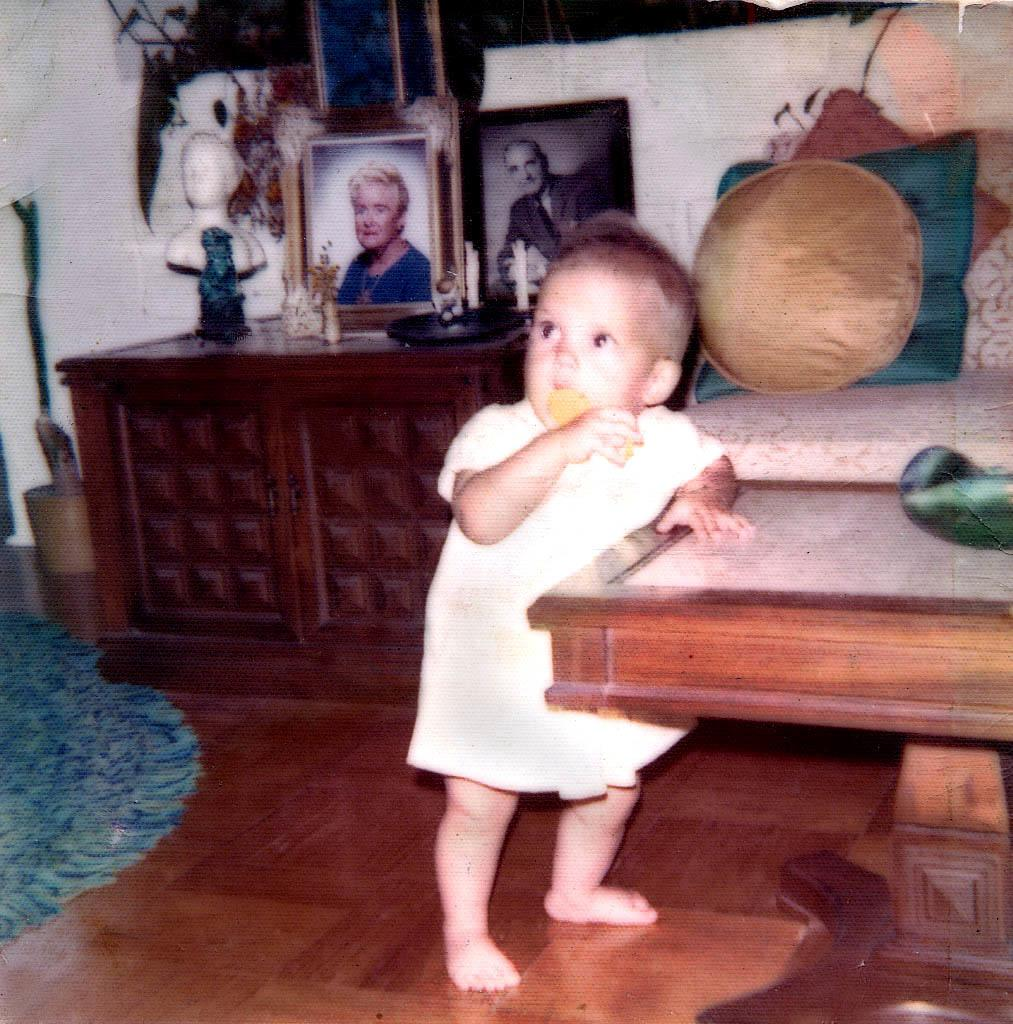What is the main subject of the image? There is a child standing in the image. What can be seen in the background of the image? There are frames and a sofa with cushions in the background of the image. What type of carriage is being used by the child in the image? There is no carriage present in the image; the child is standing. What year is depicted in the image? The provided facts do not mention any specific year, and the image does not contain any elements that would indicate a particular time period. 